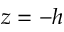<formula> <loc_0><loc_0><loc_500><loc_500>z = - h</formula> 